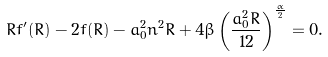Convert formula to latex. <formula><loc_0><loc_0><loc_500><loc_500>R f ^ { \prime } ( R ) - 2 f ( R ) - a _ { 0 } ^ { 2 } n ^ { 2 } R + 4 \beta \left ( \frac { a _ { 0 } ^ { 2 } R } { 1 2 } \right ) ^ { \frac { \alpha } { 2 } } = 0 .</formula> 